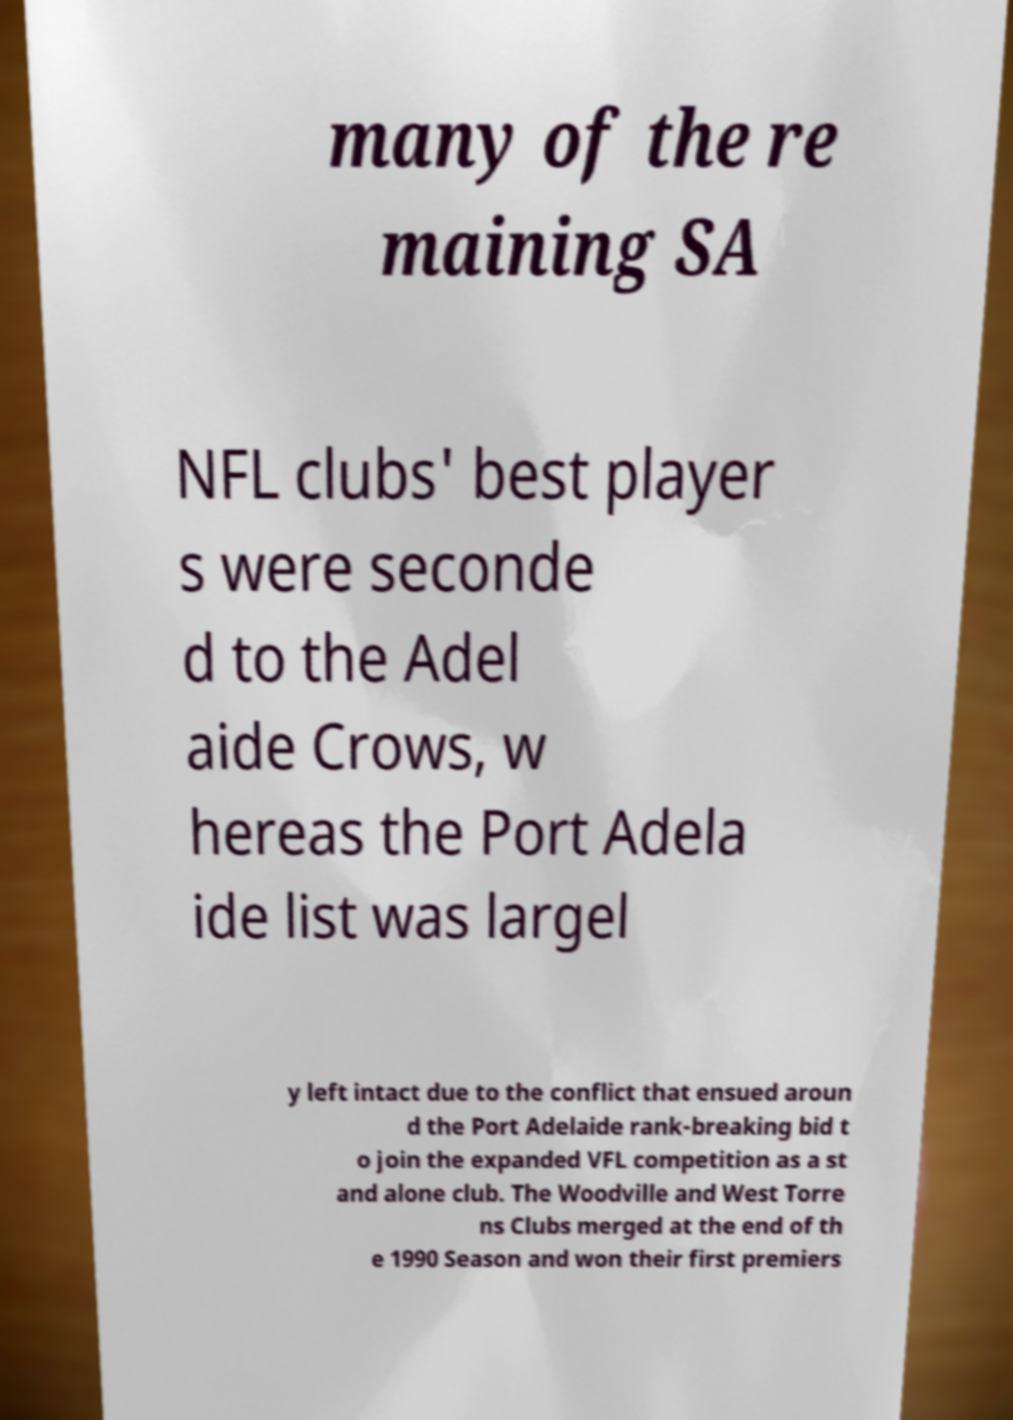I need the written content from this picture converted into text. Can you do that? many of the re maining SA NFL clubs' best player s were seconde d to the Adel aide Crows, w hereas the Port Adela ide list was largel y left intact due to the conflict that ensued aroun d the Port Adelaide rank-breaking bid t o join the expanded VFL competition as a st and alone club. The Woodville and West Torre ns Clubs merged at the end of th e 1990 Season and won their first premiers 